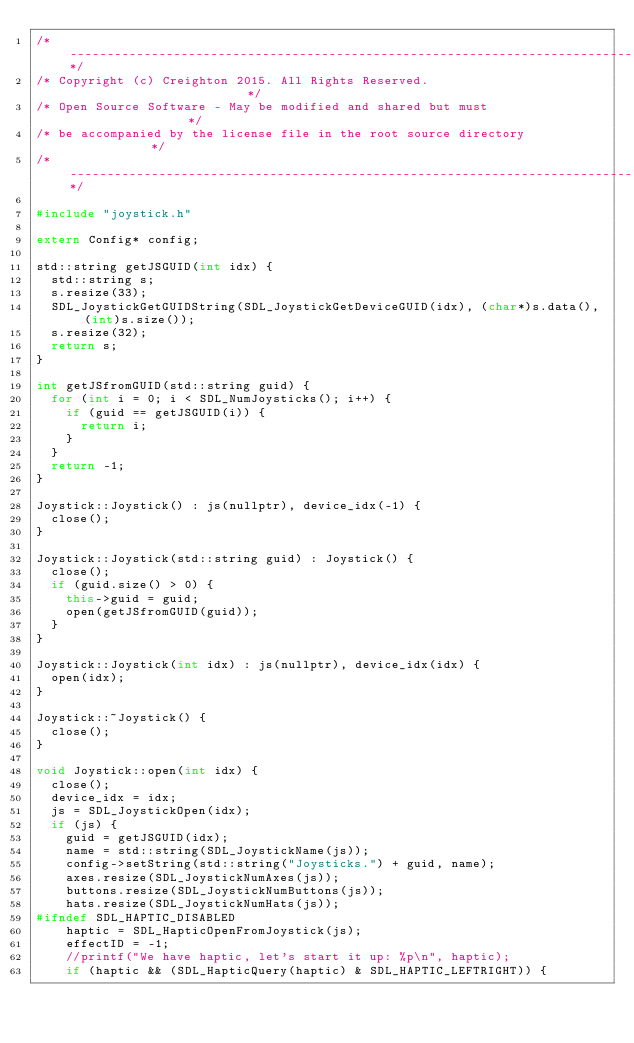Convert code to text. <code><loc_0><loc_0><loc_500><loc_500><_C++_>/*----------------------------------------------------------------------------*/
/* Copyright (c) Creighton 2015. All Rights Reserved.                         */
/* Open Source Software - May be modified and shared but must                 */
/* be accompanied by the license file in the root source directory            */
/*----------------------------------------------------------------------------*/

#include "joystick.h"

extern Config* config;

std::string getJSGUID(int idx) {
	std::string s;
	s.resize(33);
	SDL_JoystickGetGUIDString(SDL_JoystickGetDeviceGUID(idx), (char*)s.data(), (int)s.size());
	s.resize(32);
	return s;
}

int getJSfromGUID(std::string guid) {
	for (int i = 0; i < SDL_NumJoysticks(); i++) {
		if (guid == getJSGUID(i)) {
			return i;
		}
	}
	return -1;
}

Joystick::Joystick() : js(nullptr), device_idx(-1) {
	close();
}

Joystick::Joystick(std::string guid) : Joystick() {
	close();
	if (guid.size() > 0) {
		this->guid = guid;
		open(getJSfromGUID(guid));
	}
}

Joystick::Joystick(int idx) : js(nullptr), device_idx(idx) {
	open(idx);
}

Joystick::~Joystick() {
	close();
}

void Joystick::open(int idx) {
	close();
	device_idx = idx;
	js = SDL_JoystickOpen(idx);
	if (js) {
		guid = getJSGUID(idx);
		name = std::string(SDL_JoystickName(js));
		config->setString(std::string("Joysticks.") + guid, name);
		axes.resize(SDL_JoystickNumAxes(js));
		buttons.resize(SDL_JoystickNumButtons(js));
		hats.resize(SDL_JoystickNumHats(js));
#ifndef SDL_HAPTIC_DISABLED
		haptic = SDL_HapticOpenFromJoystick(js);
		effectID = -1;
		//printf("We have haptic, let's start it up: %p\n", haptic);
		if (haptic && (SDL_HapticQuery(haptic) & SDL_HAPTIC_LEFTRIGHT)) {</code> 